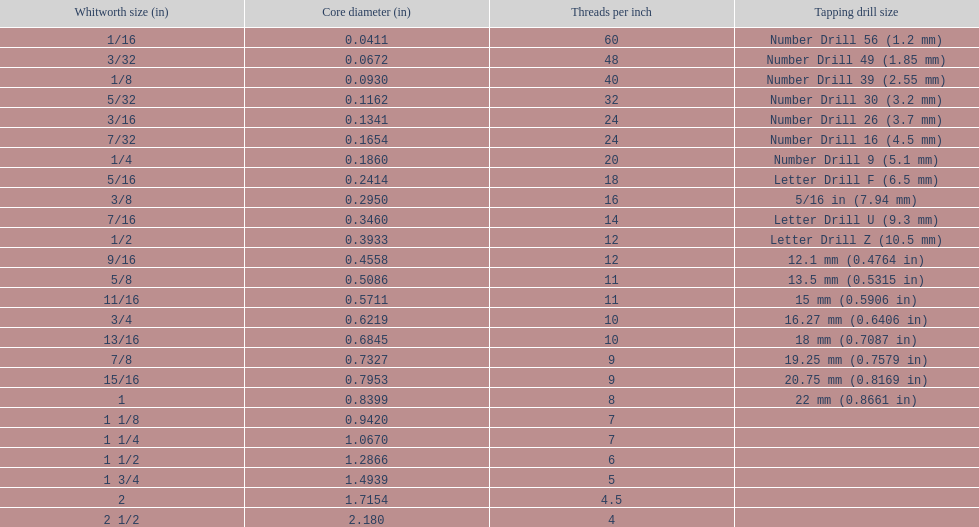What is the least core diameter (in)? 0.0411. 